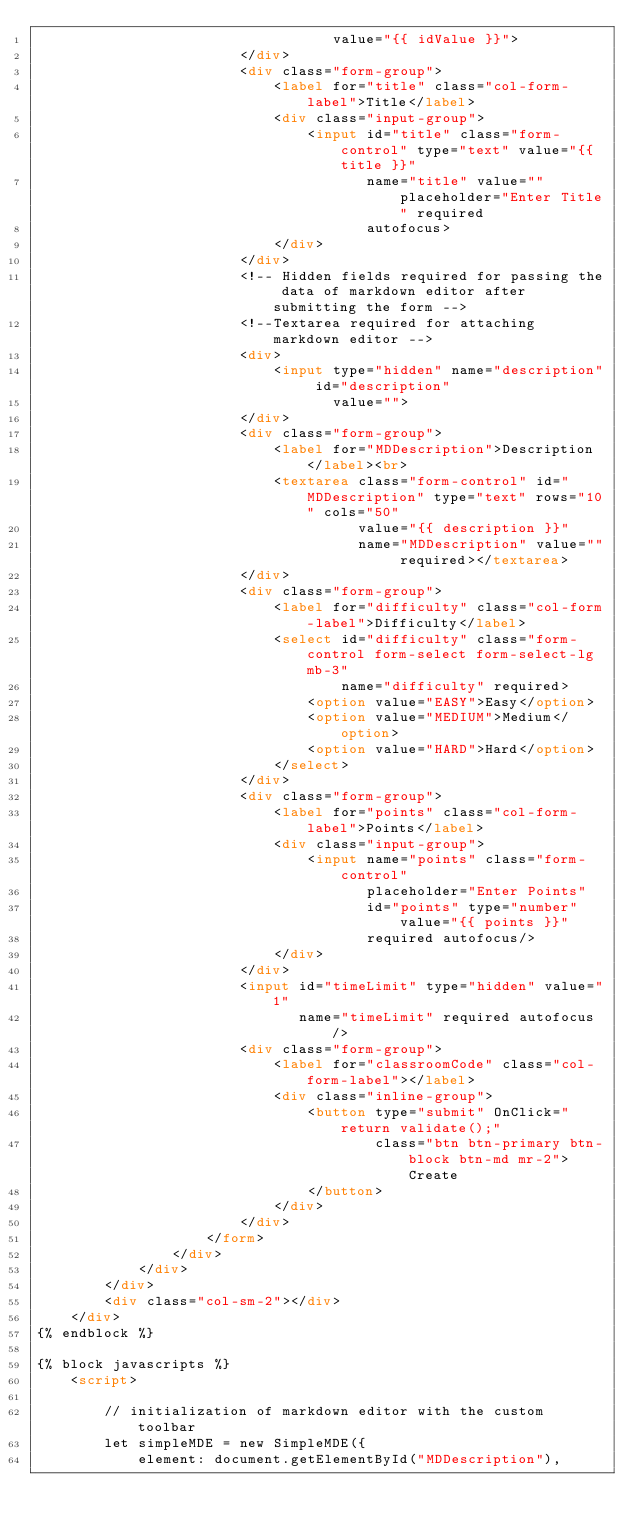Convert code to text. <code><loc_0><loc_0><loc_500><loc_500><_HTML_>                                   value="{{ idValue }}">
                        </div>
                        <div class="form-group">
                            <label for="title" class="col-form-label">Title</label>
                            <div class="input-group">
                                <input id="title" class="form-control" type="text" value="{{ title }}"
                                       name="title" value="" placeholder="Enter Title" required
                                       autofocus>
                            </div>
                        </div>
                        <!-- Hidden fields required for passing the data of markdown editor after submitting the form -->
                        <!--Textarea required for attaching markdown editor -->
                        <div>
                            <input type="hidden" name="description" id="description"
                                   value="">
                        </div>
                        <div class="form-group">
                            <label for="MDDescription">Description</label><br>
                            <textarea class="form-control" id="MDDescription" type="text" rows="10" cols="50"
                                      value="{{ description }}"
                                      name="MDDescription" value="" required></textarea>
                        </div>
                        <div class="form-group">
                            <label for="difficulty" class="col-form-label">Difficulty</label>
                            <select id="difficulty" class="form-control form-select form-select-lg mb-3"
                                    name="difficulty" required>
                                <option value="EASY">Easy</option>
                                <option value="MEDIUM">Medium</option>
                                <option value="HARD">Hard</option>
                            </select>
                        </div>
                        <div class="form-group">
                            <label for="points" class="col-form-label">Points</label>
                            <div class="input-group">
                                <input name="points" class="form-control"
                                       placeholder="Enter Points"
                                       id="points" type="number" value="{{ points }}"
                                       required autofocus/>
                            </div>
                        </div>
                        <input id="timeLimit" type="hidden" value="1"
                               name="timeLimit" required autofocus/>
                        <div class="form-group">
                            <label for="classroomCode" class="col-form-label"></label>
                            <div class="inline-group">
                                <button type="submit" OnClick="return validate();"
                                        class="btn btn-primary btn-block btn-md mr-2">Create
                                </button>
                            </div>
                        </div>
                    </form>
                </div>
            </div>
        </div>
        <div class="col-sm-2"></div>
    </div>
{% endblock %}

{% block javascripts %}
    <script>

        // initialization of markdown editor with the custom toolbar
        let simpleMDE = new SimpleMDE({
            element: document.getElementById("MDDescription"),</code> 